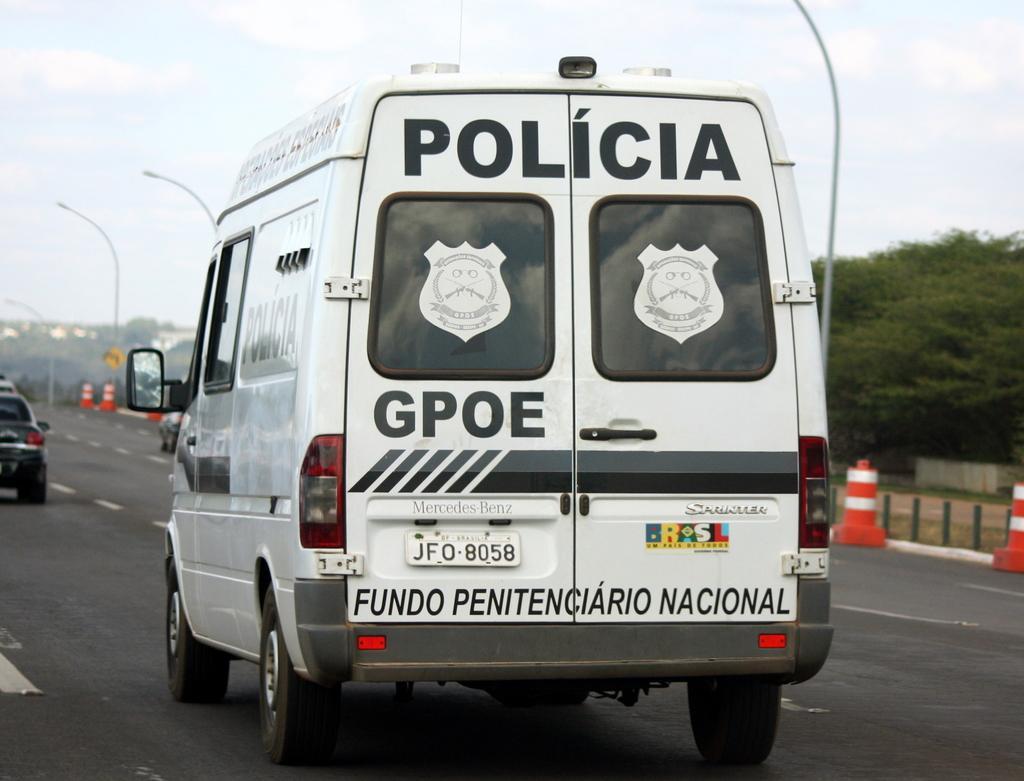Please provide a concise description of this image. In this image I can see a van which is white and black in color on the road. In the background I can see few other vehicles on the road, few traffic poles, few street light poles, few trees, few buildings and the sky. 